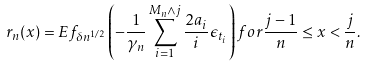<formula> <loc_0><loc_0><loc_500><loc_500>r _ { n } ( x ) = E f _ { \delta n ^ { 1 / 2 } } \left ( - \frac { 1 } { \gamma _ { n } } \sum _ { i = 1 } ^ { M _ { n } \wedge j } \frac { 2 a _ { i } } { i } \epsilon _ { t _ { i } } \right ) f o r \frac { j - 1 } { n } \leq x < \frac { j } { n } .</formula> 